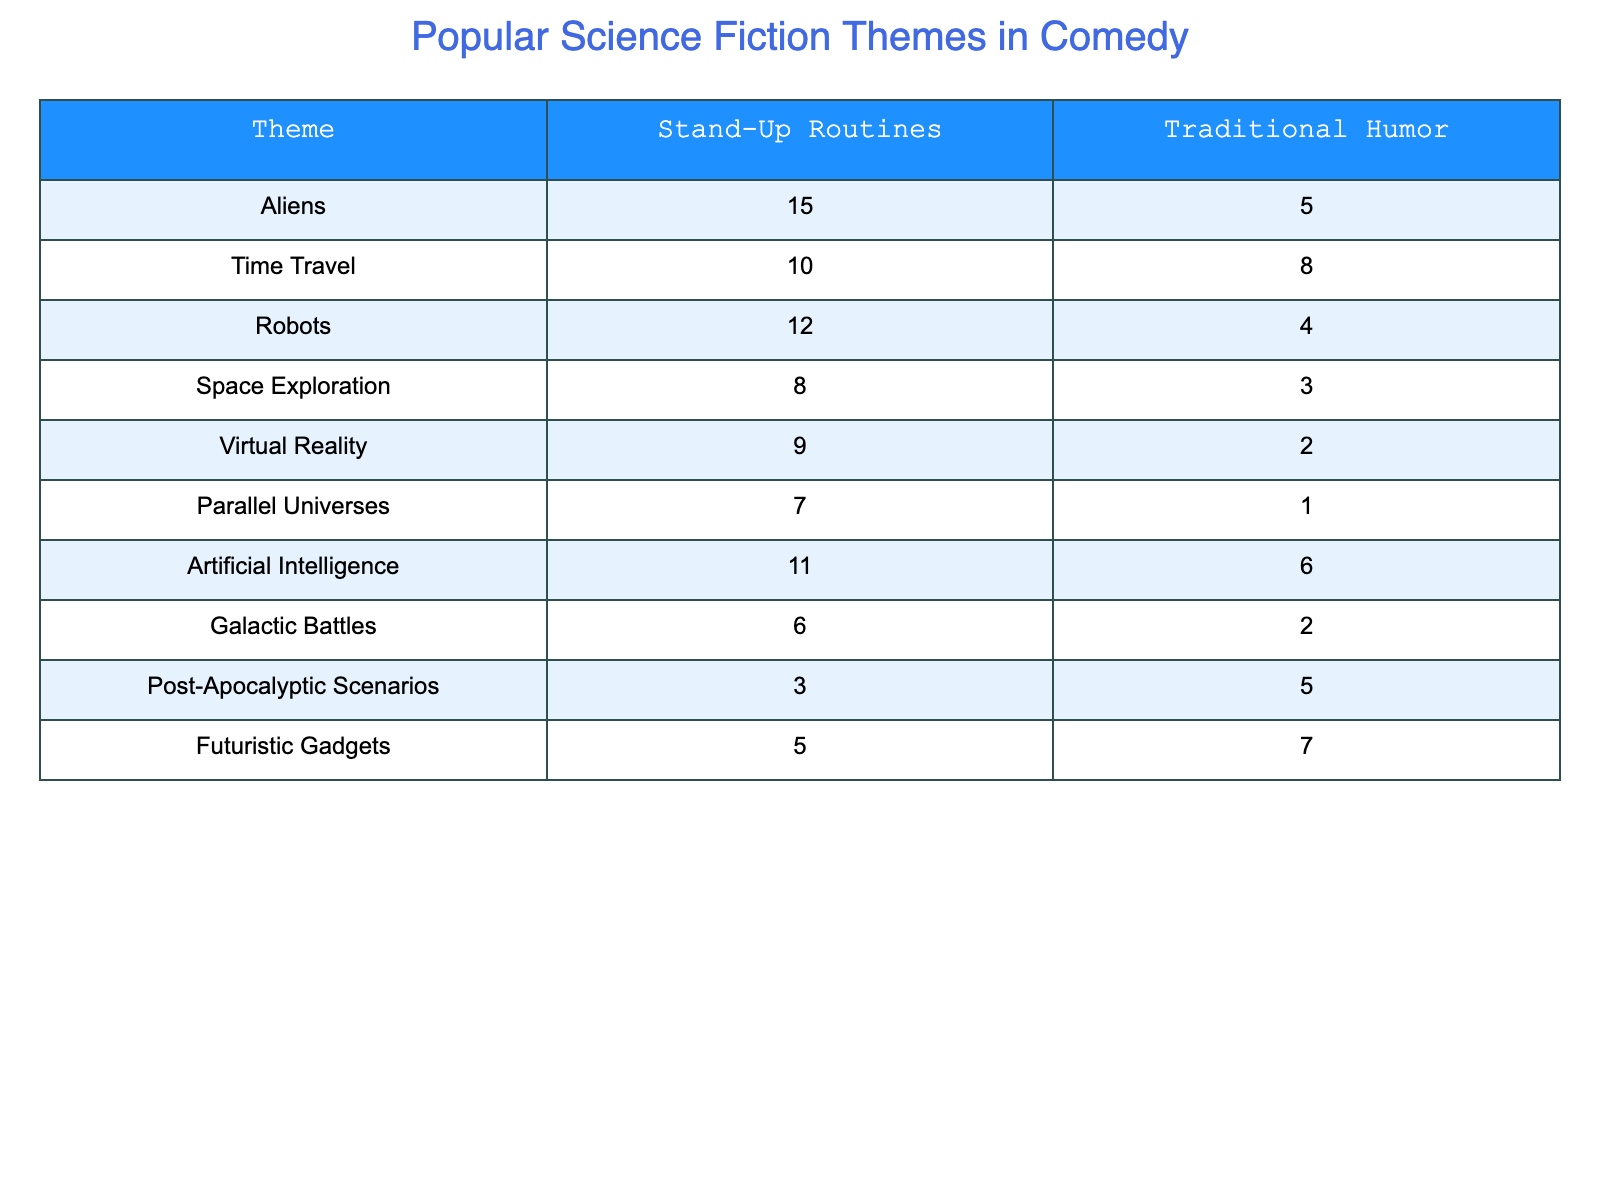What is the highest number of mentions in stand-up routines? Looking at the column for stand-up routines, the theme "Aliens" has the highest value with 15 mentions.
Answer: 15 How many total mentions of Robots and Artificial Intelligence are there in stand-up routines? The values for Robots (12) and Artificial Intelligence (11) are summed up: 12 + 11 = 23.
Answer: 23 Is the number of mentions of Space Exploration in traditional humor greater than that of Parallel Universes? Space Exploration has 3 mentions while Parallel Universes has 1 mention, thus 3 > 1 is true.
Answer: Yes What is the total count of science fiction themes presented in both stand-up routines and traditional humor? Adding the count of all themes in both columns gives us (15 + 10 + 12 + 8 + 9 + 7 + 11 + 6 + 3 + 5) for stand-up and (5 + 8 + 4 + 3 + 2 + 1 + 6 + 2 + 5 + 7) for traditional humor, resulting in a total of 86.
Answer: 86 Which theme has the smallest difference between stand-up routines and traditional humor mentions? Calculating the difference for each theme: Aliens (10), Time Travel (2), Robots (8), Space Exploration (5), Virtual Reality (7), Parallel Universes (6), Artificial Intelligence (5), Galactic Battles (4), Post-Apocalyptic (2), Futuristic Gadgets (2). The smallest difference is 2 for Time Travel.
Answer: Time Travel What is the average number of mentions across all science fiction themes in stand-up routines? There are 10 themes, and the total number of mentions in stand-up routines is 86. Thus, the average is calculated as 86/10 = 8.6.
Answer: 8.6 Do traditional humor routines include more mentions of Futuristic Gadgets than Post-Apocalyptic Scenarios? Futuristic Gadgets has 7 mentions and Post-Apocalyptic Scenarios has 5 mentions, so 7 > 5 is true.
Answer: Yes What theme has the greatest disparity in mentions between the two humor styles? By examining the differences: Aliens (10), Time Travel (2), Robots (8), Space Exploration (5), Virtual Reality (7), Parallel Universes (6), Artificial Intelligence (5), Galactic Battles (4), Post-Apocalyptic (2), Futuristic Gadgets (2), the theme with the greatest disparity is Aliens with a difference of 10.
Answer: Aliens 